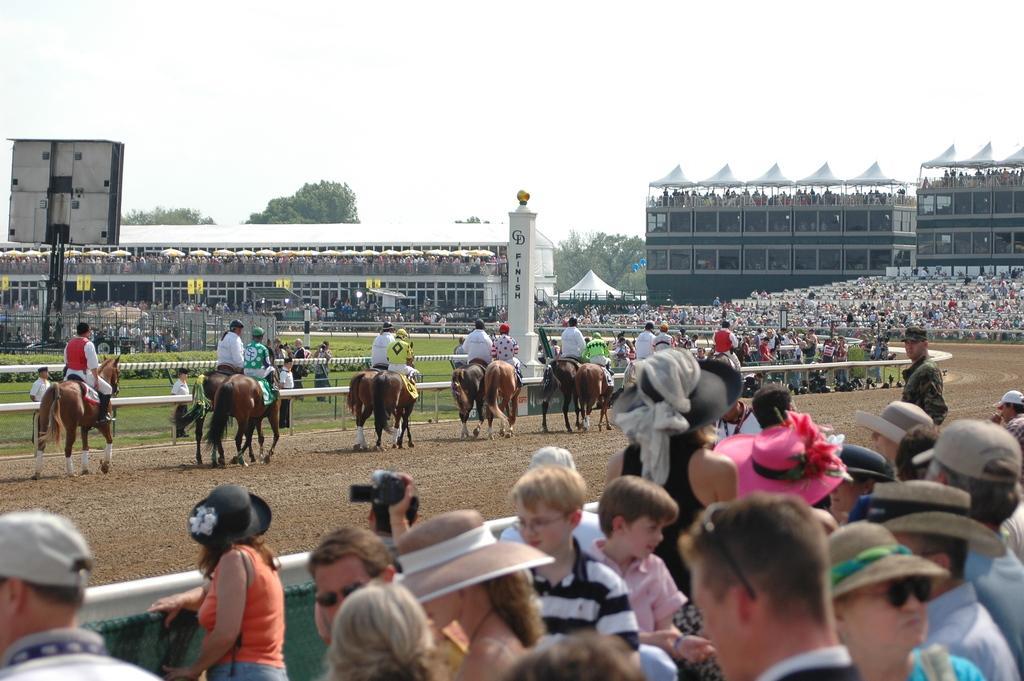Can you describe this image briefly? There are group of jockeys riding horses and there are people either side of them. 